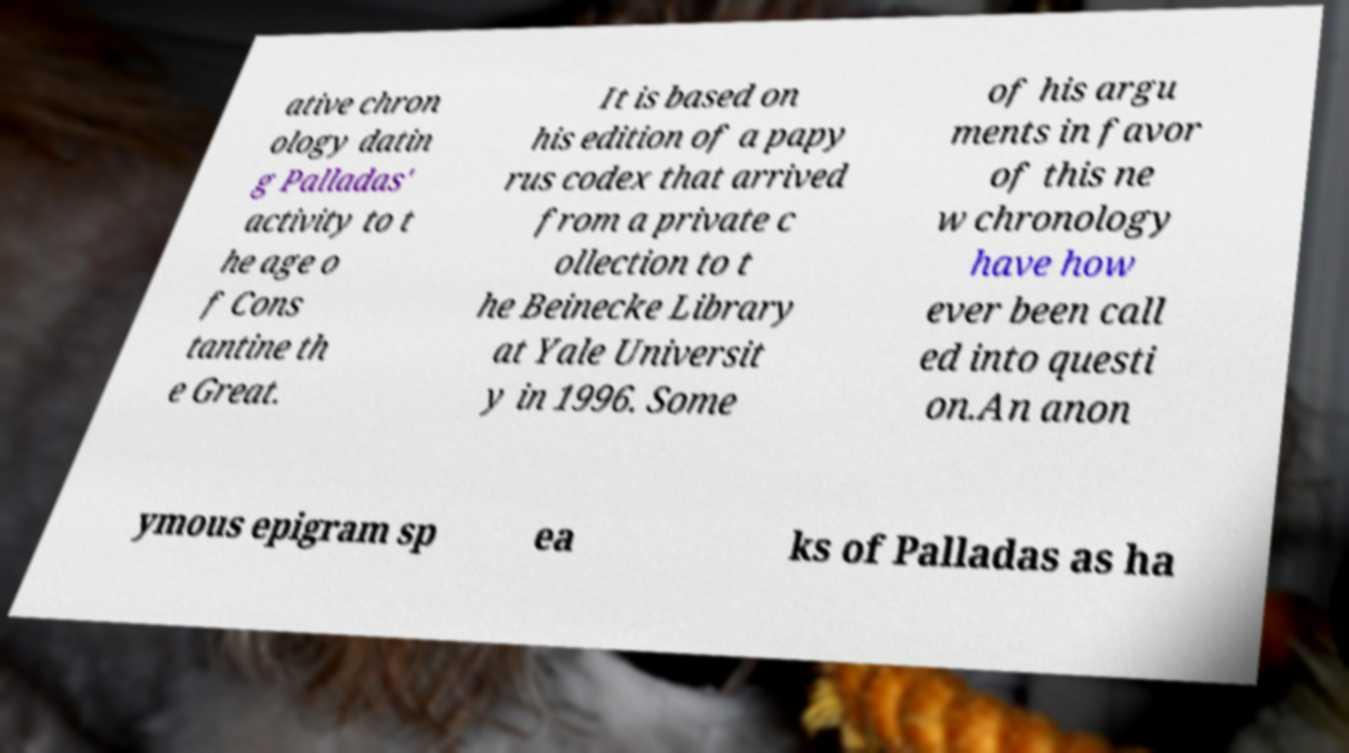I need the written content from this picture converted into text. Can you do that? ative chron ology datin g Palladas' activity to t he age o f Cons tantine th e Great. It is based on his edition of a papy rus codex that arrived from a private c ollection to t he Beinecke Library at Yale Universit y in 1996. Some of his argu ments in favor of this ne w chronology have how ever been call ed into questi on.An anon ymous epigram sp ea ks of Palladas as ha 